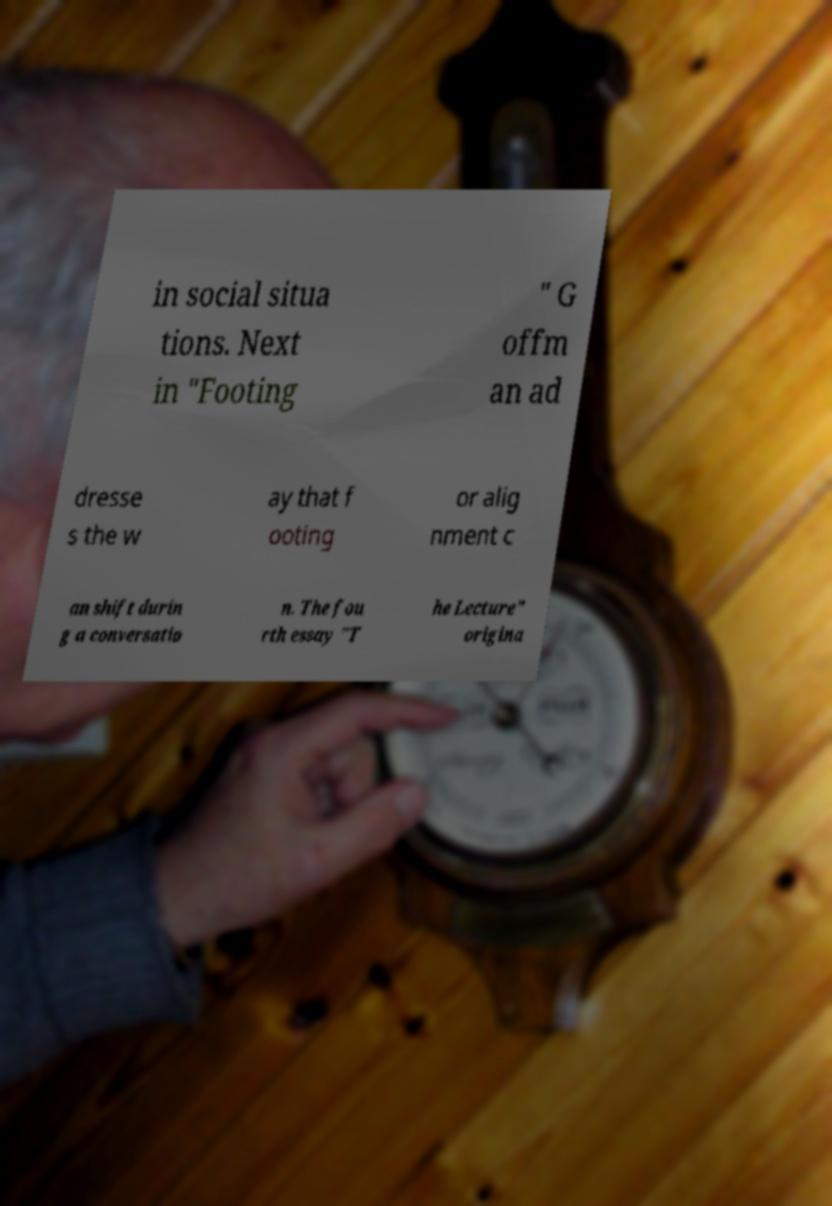Could you extract and type out the text from this image? in social situa tions. Next in "Footing " G offm an ad dresse s the w ay that f ooting or alig nment c an shift durin g a conversatio n. The fou rth essay "T he Lecture" origina 